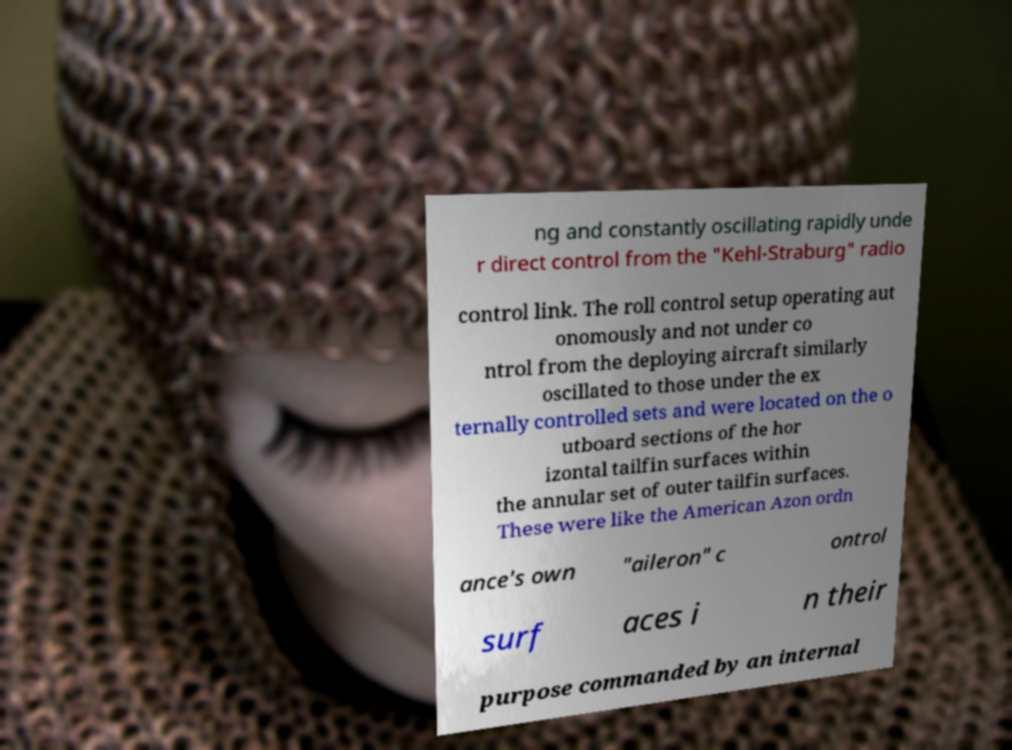Please read and relay the text visible in this image. What does it say? ng and constantly oscillating rapidly unde r direct control from the "Kehl-Straburg" radio control link. The roll control setup operating aut onomously and not under co ntrol from the deploying aircraft similarly oscillated to those under the ex ternally controlled sets and were located on the o utboard sections of the hor izontal tailfin surfaces within the annular set of outer tailfin surfaces. These were like the American Azon ordn ance's own "aileron" c ontrol surf aces i n their purpose commanded by an internal 